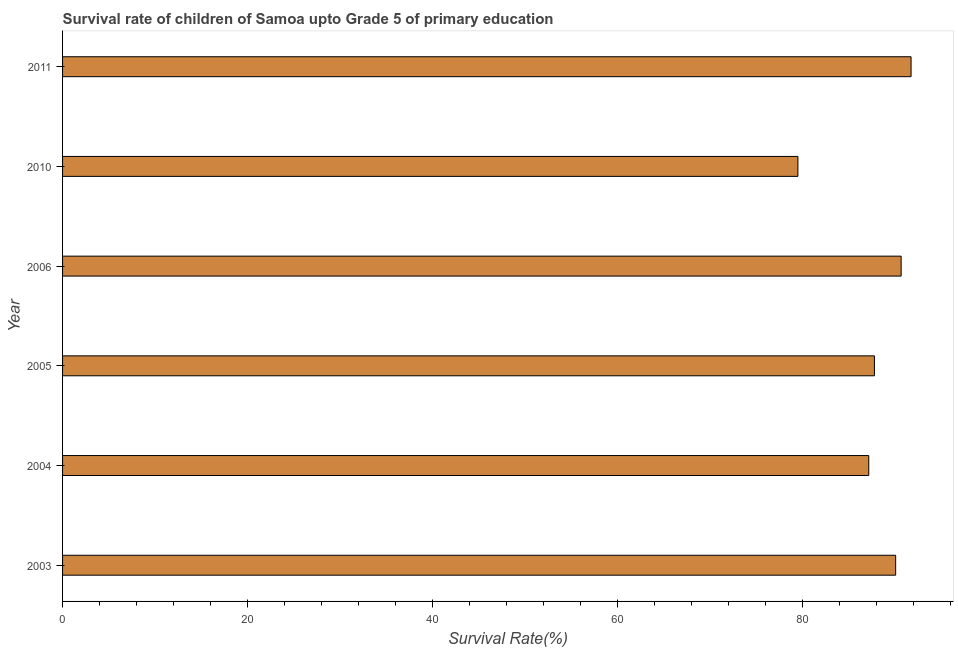What is the title of the graph?
Ensure brevity in your answer.  Survival rate of children of Samoa upto Grade 5 of primary education. What is the label or title of the X-axis?
Make the answer very short. Survival Rate(%). What is the survival rate in 2006?
Make the answer very short. 90.66. Across all years, what is the maximum survival rate?
Ensure brevity in your answer.  91.74. Across all years, what is the minimum survival rate?
Your answer should be compact. 79.5. In which year was the survival rate maximum?
Your answer should be very brief. 2011. In which year was the survival rate minimum?
Your answer should be very brief. 2010. What is the sum of the survival rate?
Your response must be concise. 526.92. What is the difference between the survival rate in 2003 and 2004?
Offer a very short reply. 2.91. What is the average survival rate per year?
Offer a terse response. 87.82. What is the median survival rate?
Your answer should be compact. 88.92. What is the ratio of the survival rate in 2004 to that in 2011?
Ensure brevity in your answer.  0.95. Is the survival rate in 2005 less than that in 2010?
Offer a terse response. No. What is the difference between the highest and the second highest survival rate?
Ensure brevity in your answer.  1.07. What is the difference between the highest and the lowest survival rate?
Provide a succinct answer. 12.23. In how many years, is the survival rate greater than the average survival rate taken over all years?
Keep it short and to the point. 3. How many bars are there?
Offer a terse response. 6. What is the difference between two consecutive major ticks on the X-axis?
Make the answer very short. 20. What is the Survival Rate(%) in 2003?
Provide a short and direct response. 90.07. What is the Survival Rate(%) of 2004?
Your response must be concise. 87.17. What is the Survival Rate(%) of 2005?
Your answer should be compact. 87.78. What is the Survival Rate(%) of 2006?
Keep it short and to the point. 90.66. What is the Survival Rate(%) in 2010?
Provide a succinct answer. 79.5. What is the Survival Rate(%) in 2011?
Give a very brief answer. 91.74. What is the difference between the Survival Rate(%) in 2003 and 2004?
Your answer should be compact. 2.91. What is the difference between the Survival Rate(%) in 2003 and 2005?
Offer a terse response. 2.3. What is the difference between the Survival Rate(%) in 2003 and 2006?
Offer a terse response. -0.59. What is the difference between the Survival Rate(%) in 2003 and 2010?
Your answer should be compact. 10.57. What is the difference between the Survival Rate(%) in 2003 and 2011?
Your answer should be compact. -1.67. What is the difference between the Survival Rate(%) in 2004 and 2005?
Your answer should be compact. -0.61. What is the difference between the Survival Rate(%) in 2004 and 2006?
Give a very brief answer. -3.5. What is the difference between the Survival Rate(%) in 2004 and 2010?
Offer a terse response. 7.66. What is the difference between the Survival Rate(%) in 2004 and 2011?
Keep it short and to the point. -4.57. What is the difference between the Survival Rate(%) in 2005 and 2006?
Provide a succinct answer. -2.89. What is the difference between the Survival Rate(%) in 2005 and 2010?
Give a very brief answer. 8.27. What is the difference between the Survival Rate(%) in 2005 and 2011?
Make the answer very short. -3.96. What is the difference between the Survival Rate(%) in 2006 and 2010?
Your response must be concise. 11.16. What is the difference between the Survival Rate(%) in 2006 and 2011?
Make the answer very short. -1.07. What is the difference between the Survival Rate(%) in 2010 and 2011?
Your answer should be compact. -12.23. What is the ratio of the Survival Rate(%) in 2003 to that in 2004?
Provide a short and direct response. 1.03. What is the ratio of the Survival Rate(%) in 2003 to that in 2006?
Your answer should be very brief. 0.99. What is the ratio of the Survival Rate(%) in 2003 to that in 2010?
Provide a short and direct response. 1.13. What is the ratio of the Survival Rate(%) in 2004 to that in 2006?
Make the answer very short. 0.96. What is the ratio of the Survival Rate(%) in 2004 to that in 2010?
Provide a short and direct response. 1.1. What is the ratio of the Survival Rate(%) in 2004 to that in 2011?
Provide a succinct answer. 0.95. What is the ratio of the Survival Rate(%) in 2005 to that in 2006?
Provide a short and direct response. 0.97. What is the ratio of the Survival Rate(%) in 2005 to that in 2010?
Offer a terse response. 1.1. What is the ratio of the Survival Rate(%) in 2005 to that in 2011?
Your response must be concise. 0.96. What is the ratio of the Survival Rate(%) in 2006 to that in 2010?
Your response must be concise. 1.14. What is the ratio of the Survival Rate(%) in 2010 to that in 2011?
Offer a very short reply. 0.87. 